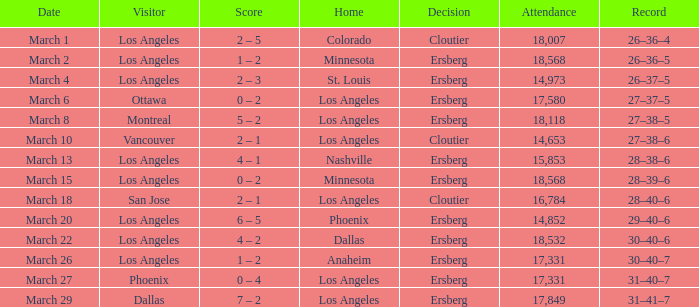Parse the table in full. {'header': ['Date', 'Visitor', 'Score', 'Home', 'Decision', 'Attendance', 'Record'], 'rows': [['March 1', 'Los Angeles', '2 – 5', 'Colorado', 'Cloutier', '18,007', '26–36–4'], ['March 2', 'Los Angeles', '1 – 2', 'Minnesota', 'Ersberg', '18,568', '26–36–5'], ['March 4', 'Los Angeles', '2 – 3', 'St. Louis', 'Ersberg', '14,973', '26–37–5'], ['March 6', 'Ottawa', '0 – 2', 'Los Angeles', 'Ersberg', '17,580', '27–37–5'], ['March 8', 'Montreal', '5 – 2', 'Los Angeles', 'Ersberg', '18,118', '27–38–5'], ['March 10', 'Vancouver', '2 – 1', 'Los Angeles', 'Cloutier', '14,653', '27–38–6'], ['March 13', 'Los Angeles', '4 – 1', 'Nashville', 'Ersberg', '15,853', '28–38–6'], ['March 15', 'Los Angeles', '0 – 2', 'Minnesota', 'Ersberg', '18,568', '28–39–6'], ['March 18', 'San Jose', '2 – 1', 'Los Angeles', 'Cloutier', '16,784', '28–40–6'], ['March 20', 'Los Angeles', '6 – 5', 'Phoenix', 'Ersberg', '14,852', '29–40–6'], ['March 22', 'Los Angeles', '4 – 2', 'Dallas', 'Ersberg', '18,532', '30–40–6'], ['March 26', 'Los Angeles', '1 – 2', 'Anaheim', 'Ersberg', '17,331', '30–40–7'], ['March 27', 'Phoenix', '0 – 4', 'Los Angeles', 'Ersberg', '17,331', '31–40–7'], ['March 29', 'Dallas', '7 – 2', 'Los Angeles', 'Ersberg', '17,849', '31–41–7']]} What is the verdict stated when the house was colorado? Cloutier. 